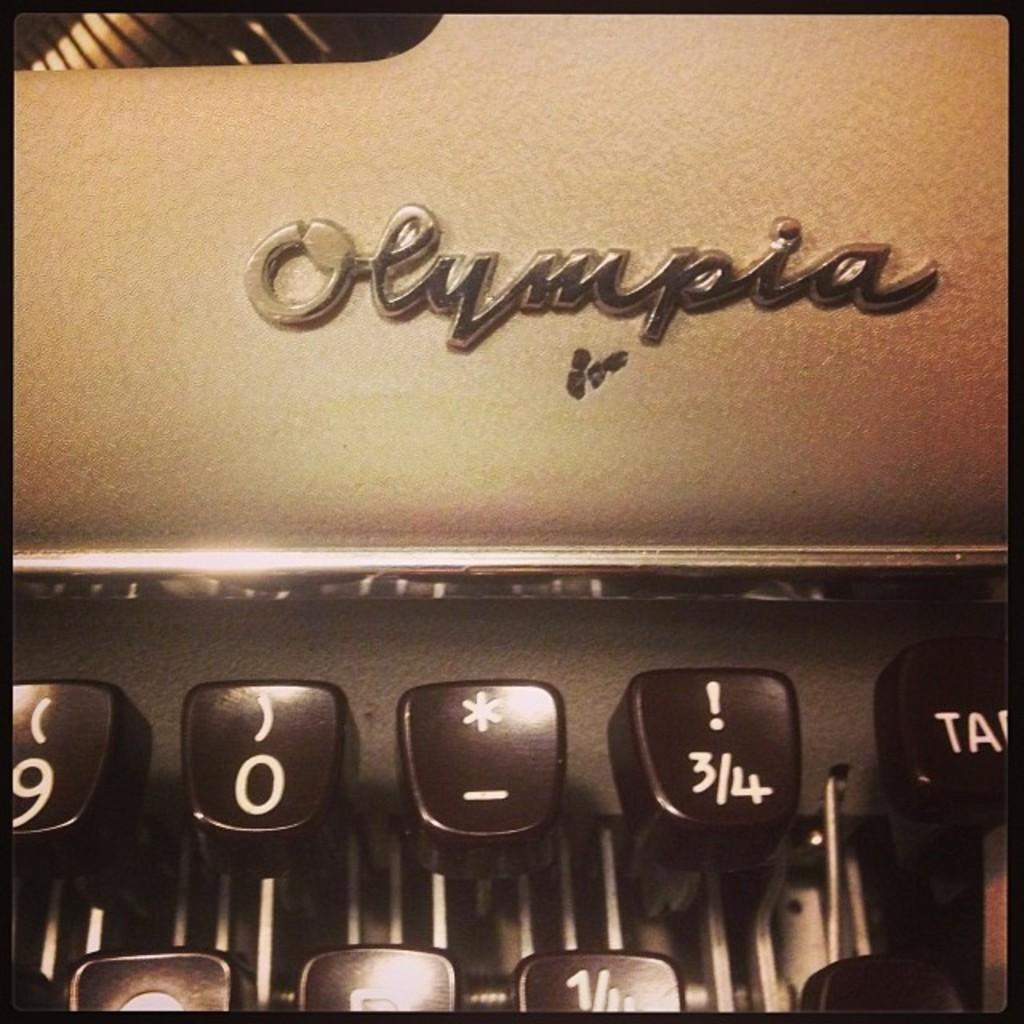<image>
Offer a succinct explanation of the picture presented. A close up of an Olympia typewriter's 9, 0, asterisk, and exclamation keys are shown. 